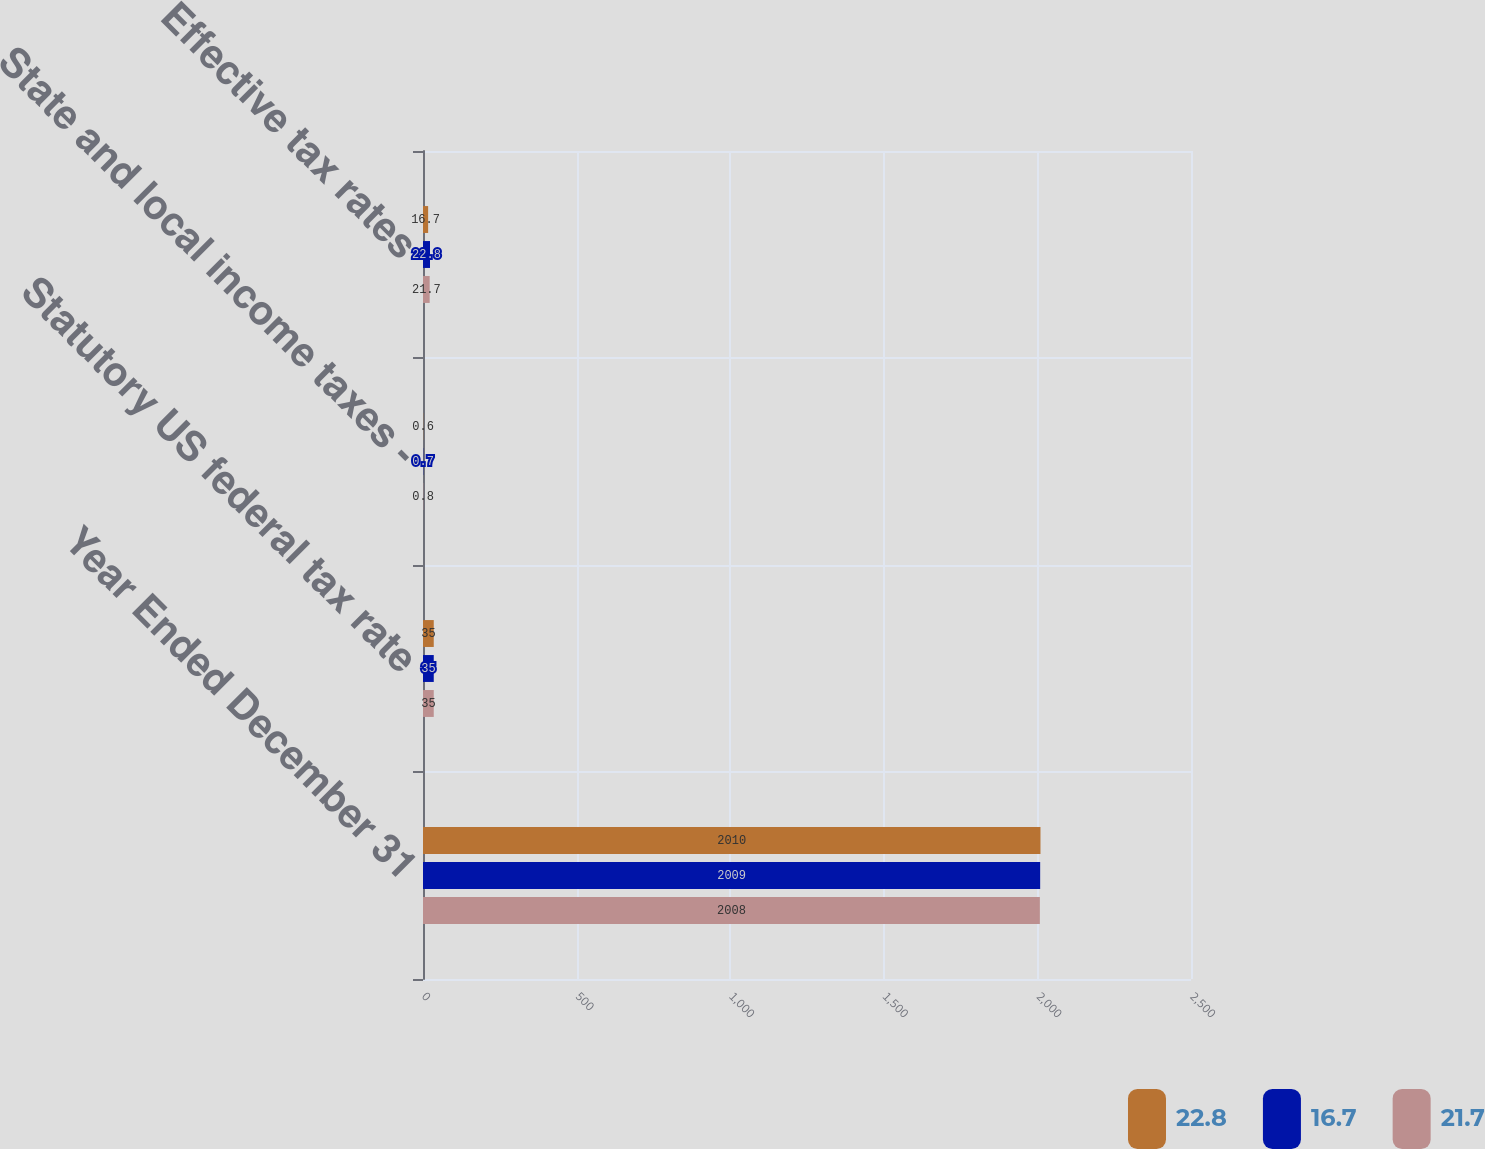Convert chart to OTSL. <chart><loc_0><loc_0><loc_500><loc_500><stacked_bar_chart><ecel><fcel>Year Ended December 31<fcel>Statutory US federal tax rate<fcel>State and local income taxes -<fcel>Effective tax rates<nl><fcel>22.8<fcel>2010<fcel>35<fcel>0.6<fcel>16.7<nl><fcel>16.7<fcel>2009<fcel>35<fcel>0.7<fcel>22.8<nl><fcel>21.7<fcel>2008<fcel>35<fcel>0.8<fcel>21.7<nl></chart> 